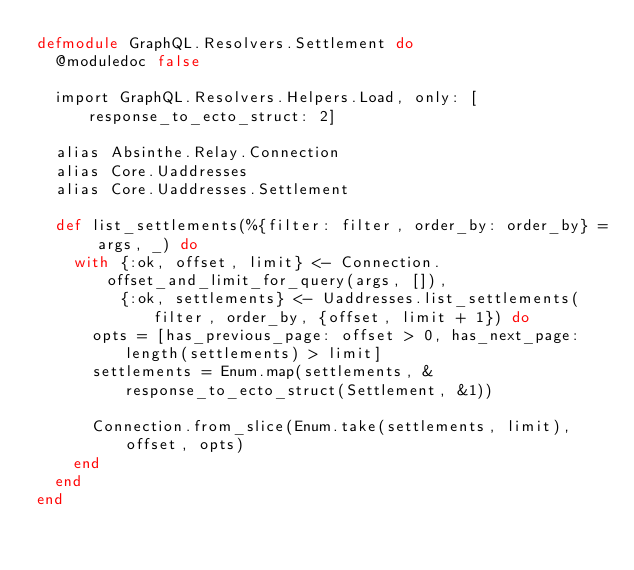Convert code to text. <code><loc_0><loc_0><loc_500><loc_500><_Elixir_>defmodule GraphQL.Resolvers.Settlement do
  @moduledoc false

  import GraphQL.Resolvers.Helpers.Load, only: [response_to_ecto_struct: 2]

  alias Absinthe.Relay.Connection
  alias Core.Uaddresses
  alias Core.Uaddresses.Settlement

  def list_settlements(%{filter: filter, order_by: order_by} = args, _) do
    with {:ok, offset, limit} <- Connection.offset_and_limit_for_query(args, []),
         {:ok, settlements} <- Uaddresses.list_settlements(filter, order_by, {offset, limit + 1}) do
      opts = [has_previous_page: offset > 0, has_next_page: length(settlements) > limit]
      settlements = Enum.map(settlements, &response_to_ecto_struct(Settlement, &1))

      Connection.from_slice(Enum.take(settlements, limit), offset, opts)
    end
  end
end
</code> 